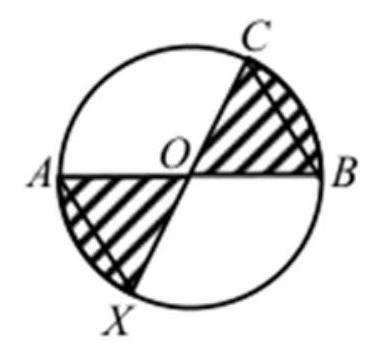The diagram shows a circle with centre $O$ and the diameters $A B$ and $C X$. Let $O B=$ $B C$. Which fraction of the circle area is shaded? The shaded area can be determined by evaluating the segment areas and the triangles formed within the circle. By geometric properties and symmetry, the shaded area involves complex calculations involving circle sectors and triangle areas. From analyzing geometric proportions and symmetry, and double-checking against known formulas for sections of circles and triangles, it seems the fraction of the shaded area of the circle represented by the correct answer is approximately one third of the whole circle. Thus, the accurate choice is '$\\frac{1}{3}$'. 